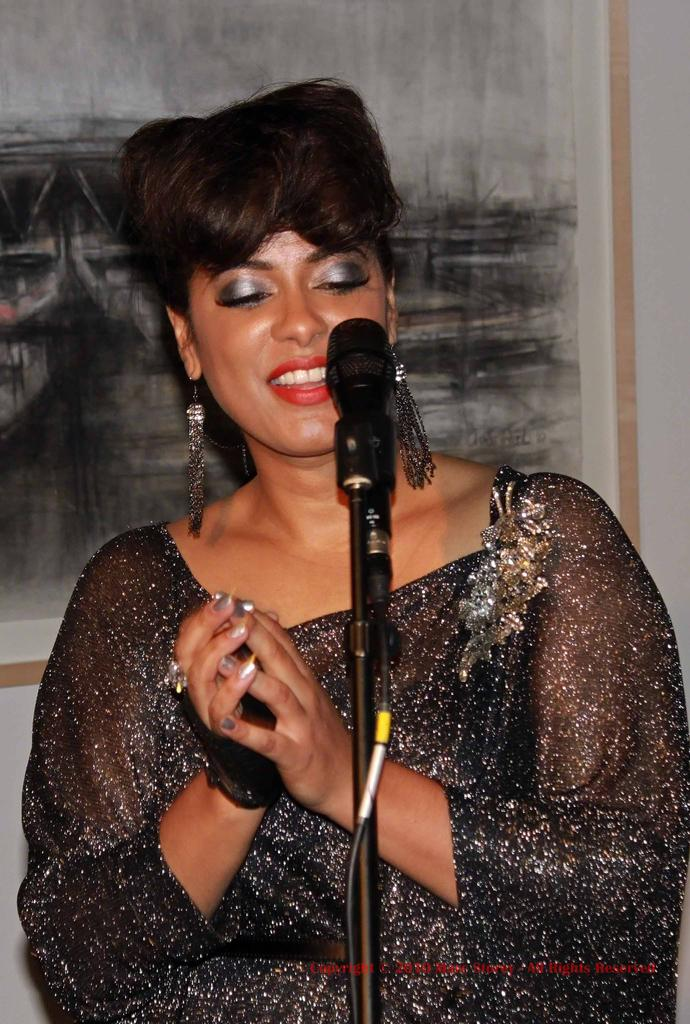Who is the main subject in the image? There is a woman in the image. What is the woman wearing? The woman is wearing a black dress. What is the woman doing in the image? The woman is singing. What object is in the center of the image? There is a microphone in the center of the image. What can be seen in the background of the image? There is a painting on the wall in the background. What type of steel is used to make the microphone in the image? There is no information about the type of steel used to make the microphone in the image, and the material of the microphone is not mentioned in the facts provided. 